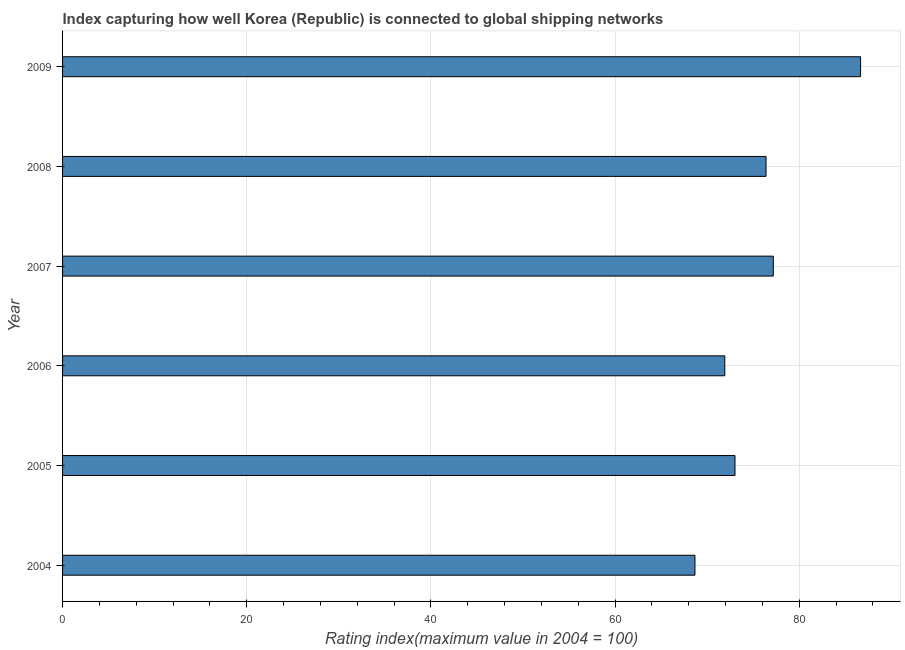Does the graph contain any zero values?
Your answer should be compact. No. Does the graph contain grids?
Your answer should be very brief. Yes. What is the title of the graph?
Offer a very short reply. Index capturing how well Korea (Republic) is connected to global shipping networks. What is the label or title of the X-axis?
Ensure brevity in your answer.  Rating index(maximum value in 2004 = 100). What is the label or title of the Y-axis?
Provide a succinct answer. Year. What is the liner shipping connectivity index in 2006?
Offer a terse response. 71.92. Across all years, what is the maximum liner shipping connectivity index?
Your response must be concise. 86.67. Across all years, what is the minimum liner shipping connectivity index?
Provide a succinct answer. 68.68. In which year was the liner shipping connectivity index maximum?
Make the answer very short. 2009. In which year was the liner shipping connectivity index minimum?
Provide a succinct answer. 2004. What is the sum of the liner shipping connectivity index?
Your response must be concise. 453.89. What is the difference between the liner shipping connectivity index in 2006 and 2009?
Provide a succinct answer. -14.75. What is the average liner shipping connectivity index per year?
Keep it short and to the point. 75.65. What is the median liner shipping connectivity index?
Make the answer very short. 74.72. What is the ratio of the liner shipping connectivity index in 2006 to that in 2008?
Your response must be concise. 0.94. Is the liner shipping connectivity index in 2004 less than that in 2005?
Offer a very short reply. Yes. What is the difference between the highest and the second highest liner shipping connectivity index?
Give a very brief answer. 9.48. Is the sum of the liner shipping connectivity index in 2004 and 2006 greater than the maximum liner shipping connectivity index across all years?
Keep it short and to the point. Yes. What is the difference between the highest and the lowest liner shipping connectivity index?
Your answer should be compact. 17.99. In how many years, is the liner shipping connectivity index greater than the average liner shipping connectivity index taken over all years?
Offer a very short reply. 3. Are all the bars in the graph horizontal?
Your answer should be very brief. Yes. Are the values on the major ticks of X-axis written in scientific E-notation?
Provide a succinct answer. No. What is the Rating index(maximum value in 2004 = 100) in 2004?
Your response must be concise. 68.68. What is the Rating index(maximum value in 2004 = 100) in 2005?
Your response must be concise. 73.03. What is the Rating index(maximum value in 2004 = 100) in 2006?
Ensure brevity in your answer.  71.92. What is the Rating index(maximum value in 2004 = 100) in 2007?
Keep it short and to the point. 77.19. What is the Rating index(maximum value in 2004 = 100) in 2008?
Provide a short and direct response. 76.4. What is the Rating index(maximum value in 2004 = 100) of 2009?
Offer a very short reply. 86.67. What is the difference between the Rating index(maximum value in 2004 = 100) in 2004 and 2005?
Provide a succinct answer. -4.35. What is the difference between the Rating index(maximum value in 2004 = 100) in 2004 and 2006?
Ensure brevity in your answer.  -3.24. What is the difference between the Rating index(maximum value in 2004 = 100) in 2004 and 2007?
Provide a succinct answer. -8.51. What is the difference between the Rating index(maximum value in 2004 = 100) in 2004 and 2008?
Provide a succinct answer. -7.72. What is the difference between the Rating index(maximum value in 2004 = 100) in 2004 and 2009?
Give a very brief answer. -17.99. What is the difference between the Rating index(maximum value in 2004 = 100) in 2005 and 2006?
Keep it short and to the point. 1.11. What is the difference between the Rating index(maximum value in 2004 = 100) in 2005 and 2007?
Give a very brief answer. -4.16. What is the difference between the Rating index(maximum value in 2004 = 100) in 2005 and 2008?
Ensure brevity in your answer.  -3.37. What is the difference between the Rating index(maximum value in 2004 = 100) in 2005 and 2009?
Ensure brevity in your answer.  -13.64. What is the difference between the Rating index(maximum value in 2004 = 100) in 2006 and 2007?
Provide a short and direct response. -5.27. What is the difference between the Rating index(maximum value in 2004 = 100) in 2006 and 2008?
Make the answer very short. -4.48. What is the difference between the Rating index(maximum value in 2004 = 100) in 2006 and 2009?
Your answer should be compact. -14.75. What is the difference between the Rating index(maximum value in 2004 = 100) in 2007 and 2008?
Make the answer very short. 0.79. What is the difference between the Rating index(maximum value in 2004 = 100) in 2007 and 2009?
Make the answer very short. -9.48. What is the difference between the Rating index(maximum value in 2004 = 100) in 2008 and 2009?
Ensure brevity in your answer.  -10.27. What is the ratio of the Rating index(maximum value in 2004 = 100) in 2004 to that in 2006?
Offer a very short reply. 0.95. What is the ratio of the Rating index(maximum value in 2004 = 100) in 2004 to that in 2007?
Your answer should be compact. 0.89. What is the ratio of the Rating index(maximum value in 2004 = 100) in 2004 to that in 2008?
Your answer should be compact. 0.9. What is the ratio of the Rating index(maximum value in 2004 = 100) in 2004 to that in 2009?
Your response must be concise. 0.79. What is the ratio of the Rating index(maximum value in 2004 = 100) in 2005 to that in 2006?
Provide a short and direct response. 1.01. What is the ratio of the Rating index(maximum value in 2004 = 100) in 2005 to that in 2007?
Offer a terse response. 0.95. What is the ratio of the Rating index(maximum value in 2004 = 100) in 2005 to that in 2008?
Make the answer very short. 0.96. What is the ratio of the Rating index(maximum value in 2004 = 100) in 2005 to that in 2009?
Your answer should be very brief. 0.84. What is the ratio of the Rating index(maximum value in 2004 = 100) in 2006 to that in 2007?
Offer a terse response. 0.93. What is the ratio of the Rating index(maximum value in 2004 = 100) in 2006 to that in 2008?
Offer a very short reply. 0.94. What is the ratio of the Rating index(maximum value in 2004 = 100) in 2006 to that in 2009?
Ensure brevity in your answer.  0.83. What is the ratio of the Rating index(maximum value in 2004 = 100) in 2007 to that in 2009?
Ensure brevity in your answer.  0.89. What is the ratio of the Rating index(maximum value in 2004 = 100) in 2008 to that in 2009?
Make the answer very short. 0.88. 